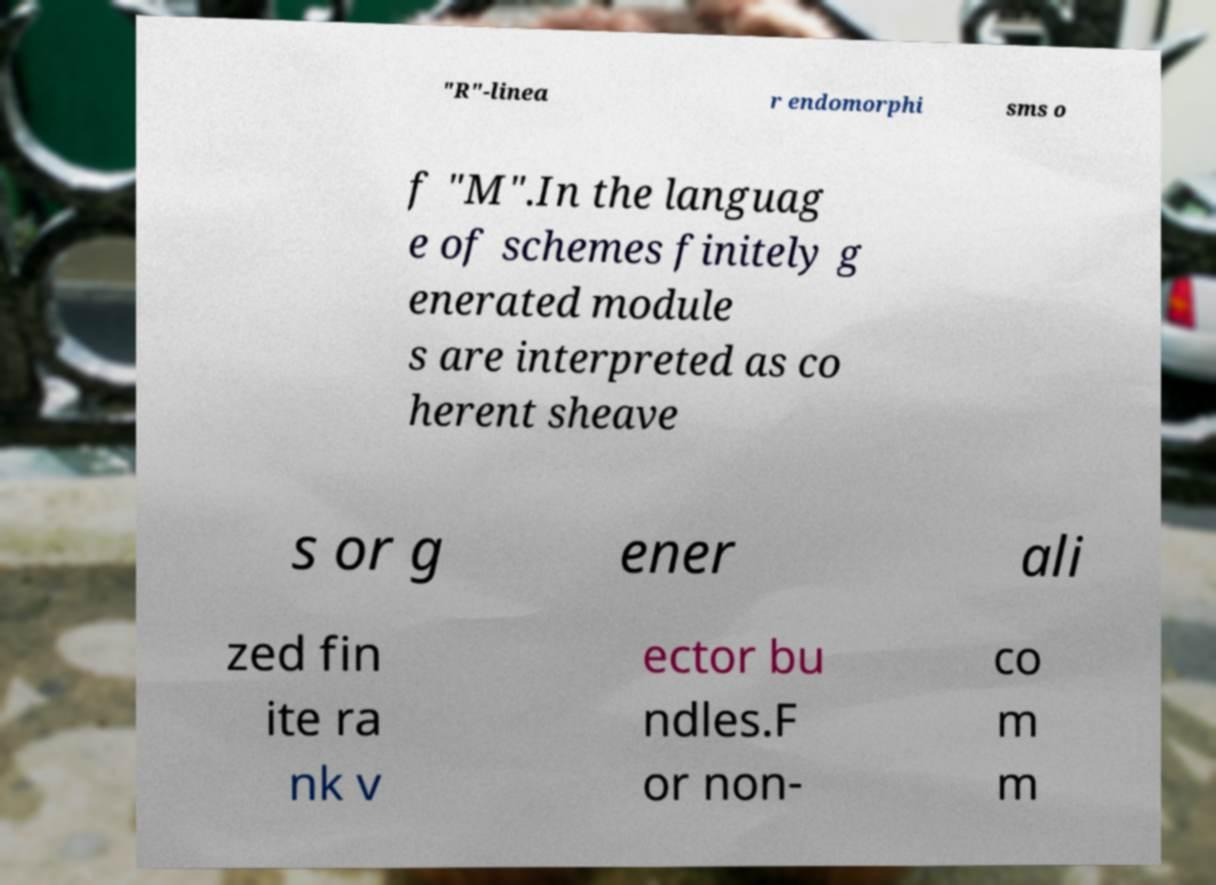Can you accurately transcribe the text from the provided image for me? "R"-linea r endomorphi sms o f "M".In the languag e of schemes finitely g enerated module s are interpreted as co herent sheave s or g ener ali zed fin ite ra nk v ector bu ndles.F or non- co m m 